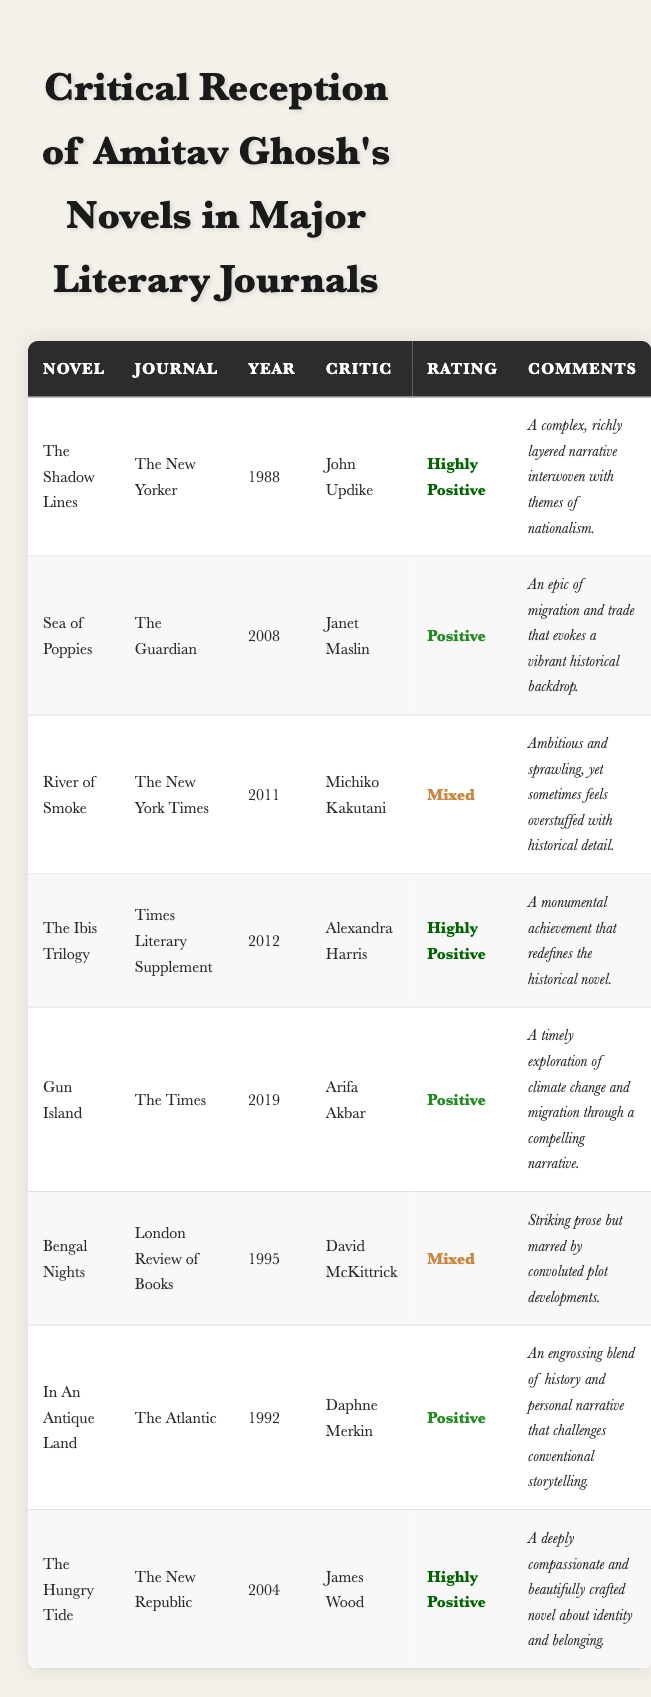What year was "The Shadow Lines" reviewed, and in which journal? The table shows that "The Shadow Lines" was reviewed in "The New Yorker" and the publication year is 1988.
Answer: 1988, The New Yorker Who wrote the review for "Sea of Poppies"? According to the table, Janet Maslin wrote the review for "Sea of Poppies."
Answer: Janet Maslin What is the overall rating given by James Wood for "The Hungry Tide"? The rating given by James Wood for "The Hungry Tide" is "Highly Positive," as indicated in the table.
Answer: Highly Positive List all novels that received a "Mixed" rating. The novels that received a "Mixed" rating are "River of Smoke" and "Bengal Nights." This can be directly found by looking at the ratings in the table.
Answer: River of Smoke, Bengal Nights In which journal did Arifa Akbar review "Gun Island," and how did she rate it? Arifa Akbar reviewed "Gun Island" in "The Times," and she rated it as "Positive," as evident in the table.
Answer: The Times, Positive What is the difference in publication years between "In An Antique Land" and "The Ibis Trilogy"? "In An Antique Land" was published in 1992 and "The Ibis Trilogy" in 2012. The difference is 2012 - 1992 = 20 years.
Answer: 20 years Which critic has given "Highly Positive" ratings for the most novels listed in the table? John Updike rated “The Shadow Lines,” Alexandra Harris rated “The Ibis Trilogy,” and James Wood rated “The Hungry Tide” all as "Highly Positive." Therefore, three critics are tied, each with one novel.
Answer: None; all critics have one “Highly Positive” rating Was there a novel reviewed in 2011 that received a "Highly Positive" rating? The table shows that "River of Smoke" was reviewed in 2011, and it received a "Mixed" rating. Thus, no novel received a "Highly Positive" rating in that year.
Answer: No Identify the novel with the most recent review and its rating. The most recent review is for "Gun Island," which was published in 2019 and received a "Positive" rating as detailed in the table.
Answer: Gun Island, Positive How many novels received a "Positive" rating in total? By examining the table, "Sea of Poppies," "Gun Island," and "In An Antique Land" received a "Positive" rating, totaling 3 novels.
Answer: 3 novels 